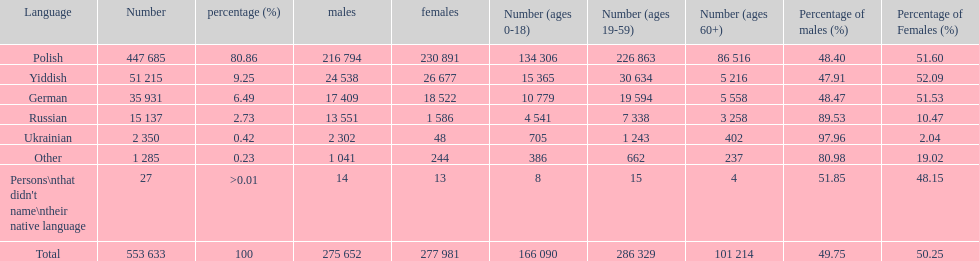How many male and female german speakers are there? 35931. 